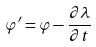<formula> <loc_0><loc_0><loc_500><loc_500>\varphi ^ { \prime } = \varphi - \frac { \partial \lambda } { \partial t }</formula> 